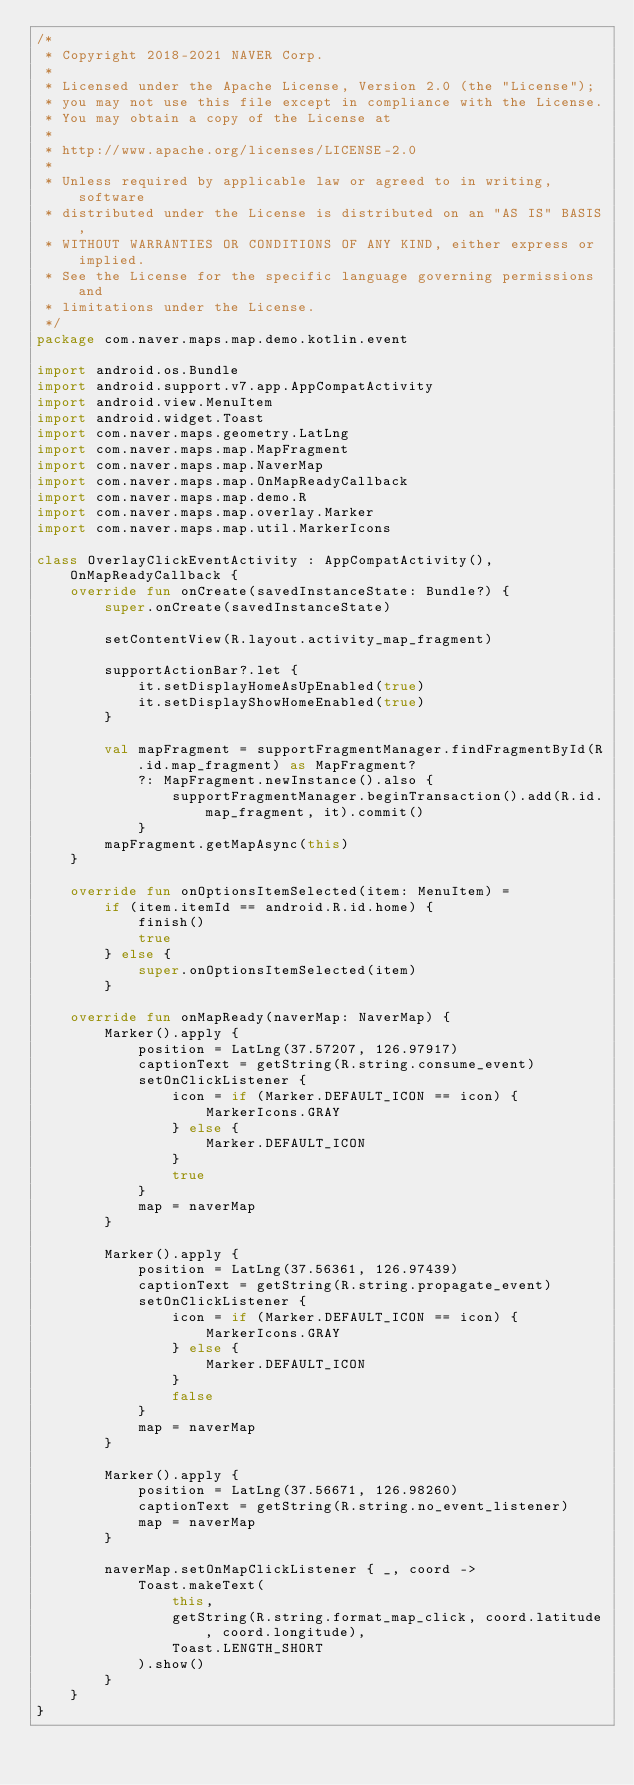<code> <loc_0><loc_0><loc_500><loc_500><_Kotlin_>/*
 * Copyright 2018-2021 NAVER Corp.
 *
 * Licensed under the Apache License, Version 2.0 (the "License");
 * you may not use this file except in compliance with the License.
 * You may obtain a copy of the License at
 *
 * http://www.apache.org/licenses/LICENSE-2.0
 *
 * Unless required by applicable law or agreed to in writing, software
 * distributed under the License is distributed on an "AS IS" BASIS,
 * WITHOUT WARRANTIES OR CONDITIONS OF ANY KIND, either express or implied.
 * See the License for the specific language governing permissions and
 * limitations under the License.
 */
package com.naver.maps.map.demo.kotlin.event

import android.os.Bundle
import android.support.v7.app.AppCompatActivity
import android.view.MenuItem
import android.widget.Toast
import com.naver.maps.geometry.LatLng
import com.naver.maps.map.MapFragment
import com.naver.maps.map.NaverMap
import com.naver.maps.map.OnMapReadyCallback
import com.naver.maps.map.demo.R
import com.naver.maps.map.overlay.Marker
import com.naver.maps.map.util.MarkerIcons

class OverlayClickEventActivity : AppCompatActivity(), OnMapReadyCallback {
    override fun onCreate(savedInstanceState: Bundle?) {
        super.onCreate(savedInstanceState)

        setContentView(R.layout.activity_map_fragment)

        supportActionBar?.let {
            it.setDisplayHomeAsUpEnabled(true)
            it.setDisplayShowHomeEnabled(true)
        }

        val mapFragment = supportFragmentManager.findFragmentById(R.id.map_fragment) as MapFragment?
            ?: MapFragment.newInstance().also {
                supportFragmentManager.beginTransaction().add(R.id.map_fragment, it).commit()
            }
        mapFragment.getMapAsync(this)
    }

    override fun onOptionsItemSelected(item: MenuItem) =
        if (item.itemId == android.R.id.home) {
            finish()
            true
        } else {
            super.onOptionsItemSelected(item)
        }

    override fun onMapReady(naverMap: NaverMap) {
        Marker().apply {
            position = LatLng(37.57207, 126.97917)
            captionText = getString(R.string.consume_event)
            setOnClickListener {
                icon = if (Marker.DEFAULT_ICON == icon) {
                    MarkerIcons.GRAY
                } else {
                    Marker.DEFAULT_ICON
                }
                true
            }
            map = naverMap
        }

        Marker().apply {
            position = LatLng(37.56361, 126.97439)
            captionText = getString(R.string.propagate_event)
            setOnClickListener {
                icon = if (Marker.DEFAULT_ICON == icon) {
                    MarkerIcons.GRAY
                } else {
                    Marker.DEFAULT_ICON
                }
                false
            }
            map = naverMap
        }

        Marker().apply {
            position = LatLng(37.56671, 126.98260)
            captionText = getString(R.string.no_event_listener)
            map = naverMap
        }

        naverMap.setOnMapClickListener { _, coord ->
            Toast.makeText(
                this,
                getString(R.string.format_map_click, coord.latitude, coord.longitude),
                Toast.LENGTH_SHORT
            ).show()
        }
    }
}
</code> 